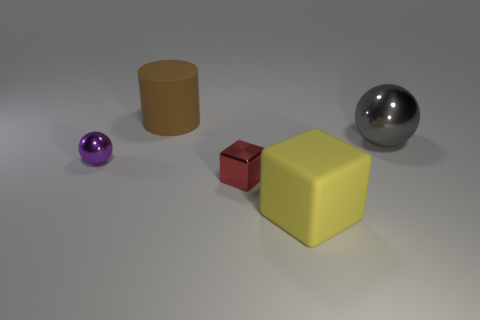Add 1 tiny metal blocks. How many objects exist? 6 Subtract all cylinders. How many objects are left? 4 Add 1 purple things. How many purple things are left? 2 Add 3 large gray shiny cubes. How many large gray shiny cubes exist? 3 Subtract 1 purple spheres. How many objects are left? 4 Subtract all purple spheres. Subtract all small spheres. How many objects are left? 3 